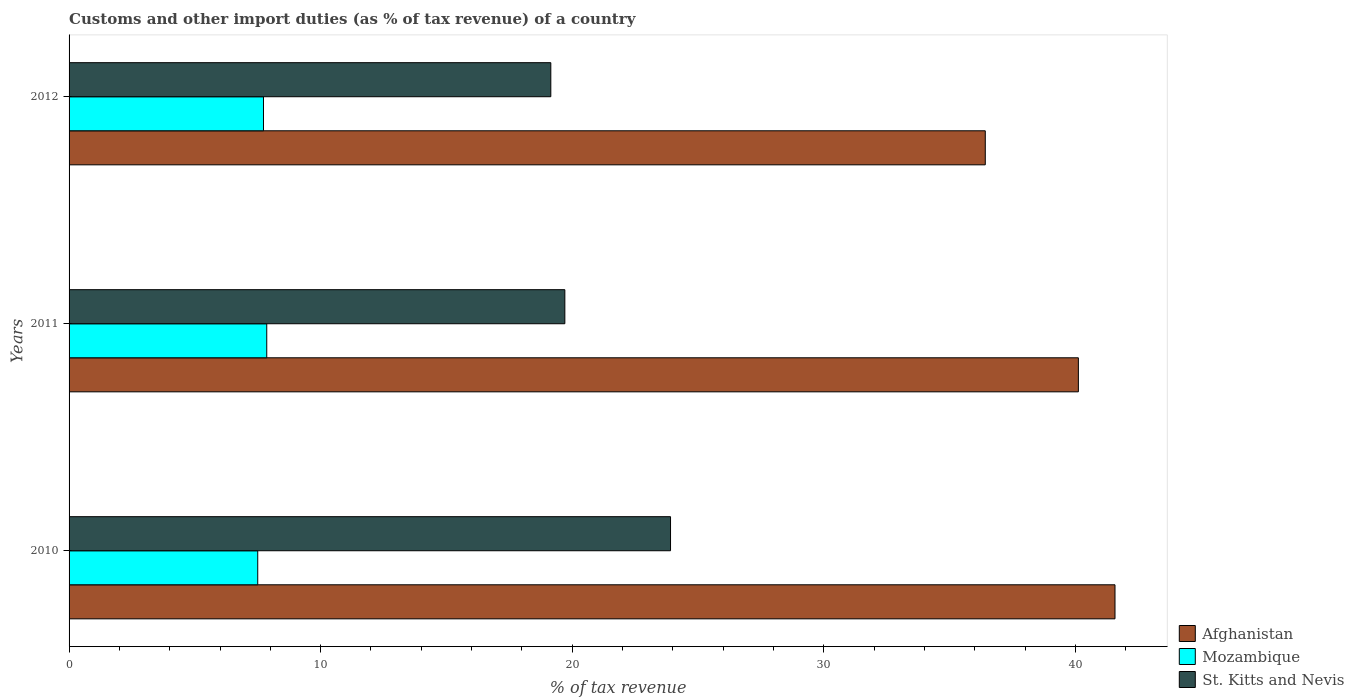How many different coloured bars are there?
Provide a succinct answer. 3. How many groups of bars are there?
Your response must be concise. 3. Are the number of bars on each tick of the Y-axis equal?
Ensure brevity in your answer.  Yes. How many bars are there on the 3rd tick from the top?
Offer a terse response. 3. What is the label of the 1st group of bars from the top?
Your response must be concise. 2012. What is the percentage of tax revenue from customs in St. Kitts and Nevis in 2012?
Give a very brief answer. 19.15. Across all years, what is the maximum percentage of tax revenue from customs in Mozambique?
Provide a succinct answer. 7.86. Across all years, what is the minimum percentage of tax revenue from customs in Mozambique?
Your answer should be compact. 7.5. In which year was the percentage of tax revenue from customs in Afghanistan maximum?
Your answer should be very brief. 2010. What is the total percentage of tax revenue from customs in St. Kitts and Nevis in the graph?
Offer a terse response. 62.76. What is the difference between the percentage of tax revenue from customs in Afghanistan in 2010 and that in 2011?
Ensure brevity in your answer.  1.46. What is the difference between the percentage of tax revenue from customs in St. Kitts and Nevis in 2010 and the percentage of tax revenue from customs in Mozambique in 2011?
Ensure brevity in your answer.  16.05. What is the average percentage of tax revenue from customs in St. Kitts and Nevis per year?
Your answer should be very brief. 20.92. In the year 2012, what is the difference between the percentage of tax revenue from customs in Afghanistan and percentage of tax revenue from customs in Mozambique?
Provide a short and direct response. 28.69. In how many years, is the percentage of tax revenue from customs in St. Kitts and Nevis greater than 14 %?
Your answer should be very brief. 3. What is the ratio of the percentage of tax revenue from customs in Mozambique in 2010 to that in 2012?
Offer a terse response. 0.97. Is the difference between the percentage of tax revenue from customs in Afghanistan in 2010 and 2011 greater than the difference between the percentage of tax revenue from customs in Mozambique in 2010 and 2011?
Ensure brevity in your answer.  Yes. What is the difference between the highest and the second highest percentage of tax revenue from customs in St. Kitts and Nevis?
Provide a succinct answer. 4.2. What is the difference between the highest and the lowest percentage of tax revenue from customs in St. Kitts and Nevis?
Keep it short and to the point. 4.76. Is the sum of the percentage of tax revenue from customs in St. Kitts and Nevis in 2010 and 2011 greater than the maximum percentage of tax revenue from customs in Mozambique across all years?
Provide a short and direct response. Yes. What does the 1st bar from the top in 2012 represents?
Keep it short and to the point. St. Kitts and Nevis. What does the 3rd bar from the bottom in 2012 represents?
Offer a very short reply. St. Kitts and Nevis. Is it the case that in every year, the sum of the percentage of tax revenue from customs in Afghanistan and percentage of tax revenue from customs in Mozambique is greater than the percentage of tax revenue from customs in St. Kitts and Nevis?
Keep it short and to the point. Yes. How many years are there in the graph?
Keep it short and to the point. 3. Are the values on the major ticks of X-axis written in scientific E-notation?
Your response must be concise. No. Does the graph contain any zero values?
Offer a very short reply. No. Does the graph contain grids?
Ensure brevity in your answer.  No. Where does the legend appear in the graph?
Offer a terse response. Bottom right. How are the legend labels stacked?
Ensure brevity in your answer.  Vertical. What is the title of the graph?
Make the answer very short. Customs and other import duties (as % of tax revenue) of a country. What is the label or title of the X-axis?
Provide a succinct answer. % of tax revenue. What is the % of tax revenue of Afghanistan in 2010?
Offer a very short reply. 41.57. What is the % of tax revenue in Mozambique in 2010?
Keep it short and to the point. 7.5. What is the % of tax revenue in St. Kitts and Nevis in 2010?
Offer a very short reply. 23.91. What is the % of tax revenue in Afghanistan in 2011?
Your answer should be compact. 40.12. What is the % of tax revenue of Mozambique in 2011?
Ensure brevity in your answer.  7.86. What is the % of tax revenue in St. Kitts and Nevis in 2011?
Your answer should be compact. 19.71. What is the % of tax revenue of Afghanistan in 2012?
Provide a short and direct response. 36.42. What is the % of tax revenue of Mozambique in 2012?
Make the answer very short. 7.73. What is the % of tax revenue of St. Kitts and Nevis in 2012?
Provide a succinct answer. 19.15. Across all years, what is the maximum % of tax revenue in Afghanistan?
Give a very brief answer. 41.57. Across all years, what is the maximum % of tax revenue in Mozambique?
Provide a short and direct response. 7.86. Across all years, what is the maximum % of tax revenue in St. Kitts and Nevis?
Provide a short and direct response. 23.91. Across all years, what is the minimum % of tax revenue of Afghanistan?
Offer a terse response. 36.42. Across all years, what is the minimum % of tax revenue of Mozambique?
Ensure brevity in your answer.  7.5. Across all years, what is the minimum % of tax revenue in St. Kitts and Nevis?
Give a very brief answer. 19.15. What is the total % of tax revenue of Afghanistan in the graph?
Your answer should be compact. 118.11. What is the total % of tax revenue in Mozambique in the graph?
Offer a terse response. 23.08. What is the total % of tax revenue in St. Kitts and Nevis in the graph?
Ensure brevity in your answer.  62.76. What is the difference between the % of tax revenue in Afghanistan in 2010 and that in 2011?
Provide a succinct answer. 1.46. What is the difference between the % of tax revenue in Mozambique in 2010 and that in 2011?
Keep it short and to the point. -0.36. What is the difference between the % of tax revenue of St. Kitts and Nevis in 2010 and that in 2011?
Your answer should be very brief. 4.2. What is the difference between the % of tax revenue in Afghanistan in 2010 and that in 2012?
Your answer should be compact. 5.16. What is the difference between the % of tax revenue of Mozambique in 2010 and that in 2012?
Your response must be concise. -0.23. What is the difference between the % of tax revenue of St. Kitts and Nevis in 2010 and that in 2012?
Your answer should be compact. 4.76. What is the difference between the % of tax revenue in Afghanistan in 2011 and that in 2012?
Your response must be concise. 3.7. What is the difference between the % of tax revenue in Mozambique in 2011 and that in 2012?
Your answer should be very brief. 0.13. What is the difference between the % of tax revenue in St. Kitts and Nevis in 2011 and that in 2012?
Make the answer very short. 0.56. What is the difference between the % of tax revenue of Afghanistan in 2010 and the % of tax revenue of Mozambique in 2011?
Provide a succinct answer. 33.72. What is the difference between the % of tax revenue of Afghanistan in 2010 and the % of tax revenue of St. Kitts and Nevis in 2011?
Ensure brevity in your answer.  21.87. What is the difference between the % of tax revenue in Mozambique in 2010 and the % of tax revenue in St. Kitts and Nevis in 2011?
Offer a very short reply. -12.21. What is the difference between the % of tax revenue in Afghanistan in 2010 and the % of tax revenue in Mozambique in 2012?
Make the answer very short. 33.85. What is the difference between the % of tax revenue of Afghanistan in 2010 and the % of tax revenue of St. Kitts and Nevis in 2012?
Offer a very short reply. 22.43. What is the difference between the % of tax revenue in Mozambique in 2010 and the % of tax revenue in St. Kitts and Nevis in 2012?
Your response must be concise. -11.65. What is the difference between the % of tax revenue of Afghanistan in 2011 and the % of tax revenue of Mozambique in 2012?
Make the answer very short. 32.39. What is the difference between the % of tax revenue of Afghanistan in 2011 and the % of tax revenue of St. Kitts and Nevis in 2012?
Provide a short and direct response. 20.97. What is the difference between the % of tax revenue of Mozambique in 2011 and the % of tax revenue of St. Kitts and Nevis in 2012?
Give a very brief answer. -11.29. What is the average % of tax revenue in Afghanistan per year?
Ensure brevity in your answer.  39.37. What is the average % of tax revenue in Mozambique per year?
Offer a very short reply. 7.69. What is the average % of tax revenue in St. Kitts and Nevis per year?
Your response must be concise. 20.92. In the year 2010, what is the difference between the % of tax revenue of Afghanistan and % of tax revenue of Mozambique?
Keep it short and to the point. 34.07. In the year 2010, what is the difference between the % of tax revenue in Afghanistan and % of tax revenue in St. Kitts and Nevis?
Offer a terse response. 17.67. In the year 2010, what is the difference between the % of tax revenue of Mozambique and % of tax revenue of St. Kitts and Nevis?
Offer a terse response. -16.41. In the year 2011, what is the difference between the % of tax revenue in Afghanistan and % of tax revenue in Mozambique?
Give a very brief answer. 32.26. In the year 2011, what is the difference between the % of tax revenue of Afghanistan and % of tax revenue of St. Kitts and Nevis?
Your answer should be compact. 20.41. In the year 2011, what is the difference between the % of tax revenue in Mozambique and % of tax revenue in St. Kitts and Nevis?
Your response must be concise. -11.85. In the year 2012, what is the difference between the % of tax revenue of Afghanistan and % of tax revenue of Mozambique?
Your answer should be very brief. 28.69. In the year 2012, what is the difference between the % of tax revenue in Afghanistan and % of tax revenue in St. Kitts and Nevis?
Offer a terse response. 17.27. In the year 2012, what is the difference between the % of tax revenue in Mozambique and % of tax revenue in St. Kitts and Nevis?
Provide a succinct answer. -11.42. What is the ratio of the % of tax revenue in Afghanistan in 2010 to that in 2011?
Make the answer very short. 1.04. What is the ratio of the % of tax revenue of Mozambique in 2010 to that in 2011?
Provide a short and direct response. 0.95. What is the ratio of the % of tax revenue in St. Kitts and Nevis in 2010 to that in 2011?
Your answer should be compact. 1.21. What is the ratio of the % of tax revenue of Afghanistan in 2010 to that in 2012?
Your response must be concise. 1.14. What is the ratio of the % of tax revenue of Mozambique in 2010 to that in 2012?
Make the answer very short. 0.97. What is the ratio of the % of tax revenue of St. Kitts and Nevis in 2010 to that in 2012?
Ensure brevity in your answer.  1.25. What is the ratio of the % of tax revenue of Afghanistan in 2011 to that in 2012?
Your answer should be compact. 1.1. What is the ratio of the % of tax revenue in Mozambique in 2011 to that in 2012?
Your answer should be very brief. 1.02. What is the ratio of the % of tax revenue of St. Kitts and Nevis in 2011 to that in 2012?
Your answer should be compact. 1.03. What is the difference between the highest and the second highest % of tax revenue of Afghanistan?
Give a very brief answer. 1.46. What is the difference between the highest and the second highest % of tax revenue of Mozambique?
Offer a very short reply. 0.13. What is the difference between the highest and the second highest % of tax revenue of St. Kitts and Nevis?
Ensure brevity in your answer.  4.2. What is the difference between the highest and the lowest % of tax revenue of Afghanistan?
Keep it short and to the point. 5.16. What is the difference between the highest and the lowest % of tax revenue in Mozambique?
Provide a short and direct response. 0.36. What is the difference between the highest and the lowest % of tax revenue in St. Kitts and Nevis?
Your answer should be compact. 4.76. 